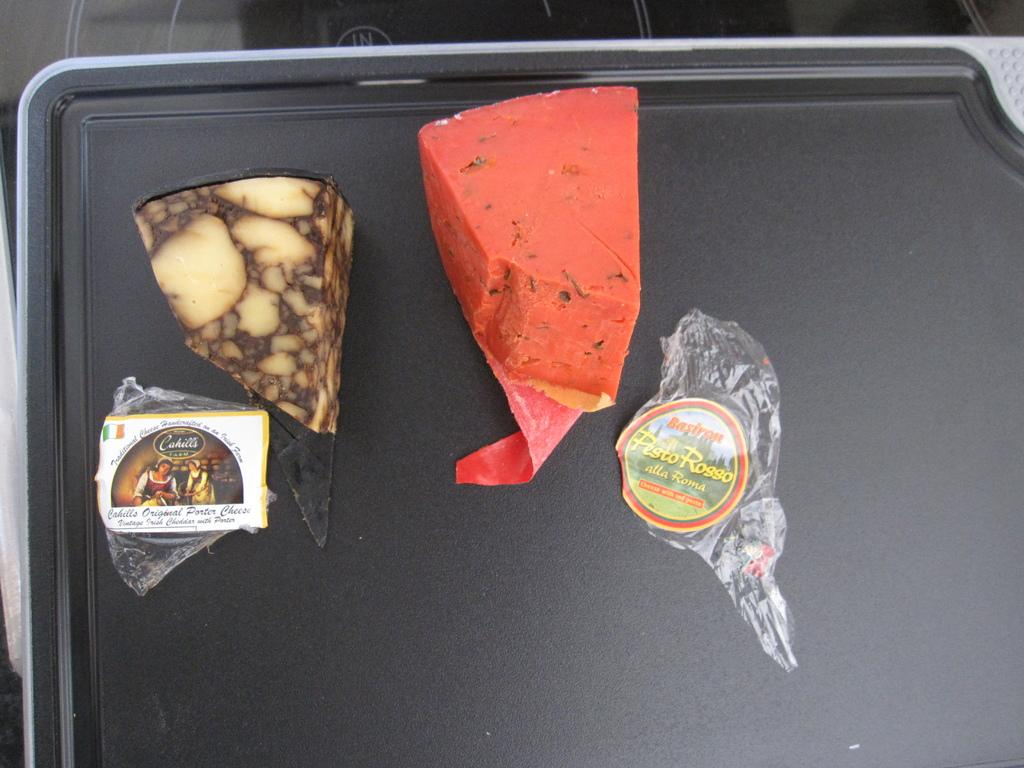What is the color of the main object in the image? There is a black object in the image. What is placed on the black object? There is an orange object on the black object. What type of items are made of plastic in the image? There are plastic items in the image. Are there any other black objects in the image? Yes, there is another black object in the image. What type of furniture is visible in the image? There is no furniture present in the image. Can you tell me how many toes are visible on the black object? There are no toes visible in the image, as the black object is not a living being. 